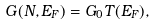<formula> <loc_0><loc_0><loc_500><loc_500>G ( N , E _ { F } ) = G _ { 0 } T ( E _ { F } ) ,</formula> 